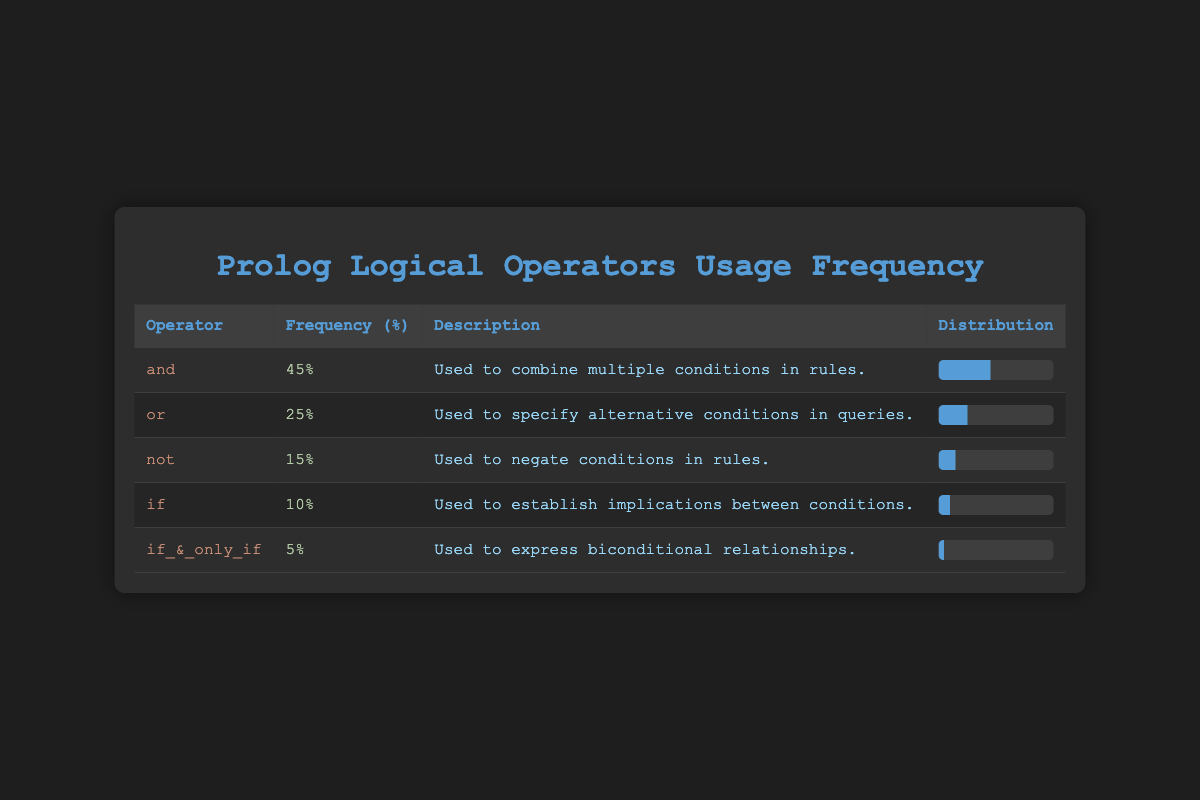What is the frequency of the logical operator "and"? The table indicates that the frequency of the logical operator "and" is specifically listed as 45%.
Answer: 45% Which logical operator has the lowest frequency of usage? By examining the frequency column in the table, "if_&_only_if" clearly has the lowest frequency, listed at 5%.
Answer: if_&_only_if What is the total frequency of the logical operators "or" and "not"? To find the total frequency, we add the frequencies of "or" (25%) and "not" (15%): 25 + 15 = 40.
Answer: 40 Is the frequency of the operator "if" greater than the frequency of the operator "not"? The frequency of "if" is 10%, and the frequency of "not" is 15%; since 10% is less than 15%, the statement is false.
Answer: No What is the average frequency of the logical operators presented in the table? To find the average frequency, first sum all the frequencies: 45 + 25 + 15 + 10 + 5 = 100. Then divide by the number of operators (5): 100 / 5 = 20.
Answer: 20 If we consider only the operators "and" and "or", what percentage of the total frequency do they represent? The combined frequency of "and" (45%) and "or" (25%) is 70%. Since the total frequency is 100%, the combined percentage is simply 70%.
Answer: 70 Which two operators together have a frequency of 35%? Checking the combinations of operators, "and" (45%) and "if" (10%) together exceed 35%. Instead, "or" (25%) and "not" (15%) combine to equal 40%, which is still more than 35%. Ultimately, the only valid combination yielding exactly 35% through subtraction is "or" (25%) minus a non-usage indicator — there are no two operators that satisfy exactly 35%.
Answer: None What percentage of logical usage is represented by "if" and "if_&_only_if"? Summing the frequencies of "if" (10%) and "if_&_only_if" (5%) gives 15%, showing their combined percentage of logical operator usage is 15%.
Answer: 15 Which operator has a higher frequency, "not" or "if"? Reviewing the frequencies, "not" is at 15% while "if" is only at 10%. Since 15% is greater than 10%, "not" has the higher frequency.
Answer: not 